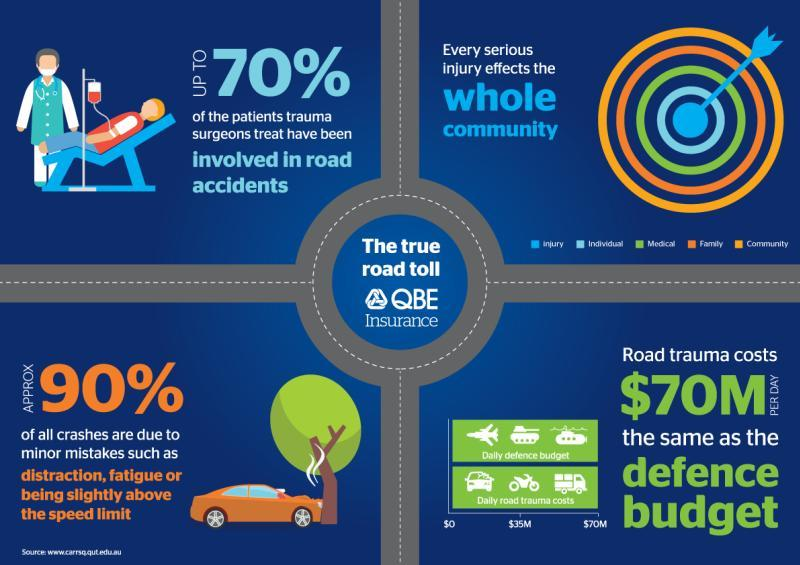Which color is used to represent medical-blue, green, orange, or white?
Answer the question with a short phrase. green What percentage of crashes are due to major mistakes? 10% 